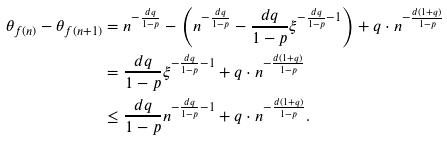<formula> <loc_0><loc_0><loc_500><loc_500>\theta _ { f ( n ) } - \theta _ { f ( n + 1 ) } & = n ^ { - \frac { d q } { 1 - p } } - \left ( n ^ { - \frac { d q } { 1 - p } } - \frac { d q } { 1 - p } \xi ^ { - \frac { d q } { 1 - p } - 1 } \right ) + q \cdot n ^ { - \frac { d ( 1 + q ) } { 1 - p } } \\ & = \frac { d q } { 1 - p } \xi ^ { - \frac { d q } { 1 - p } - 1 } + q \cdot n ^ { - \frac { d ( 1 + q ) } { 1 - p } } \\ & \leq \frac { d q } { 1 - p } n ^ { - \frac { d q } { 1 - p } - 1 } + q \cdot n ^ { - \frac { d ( 1 + q ) } { 1 - p } } .</formula> 